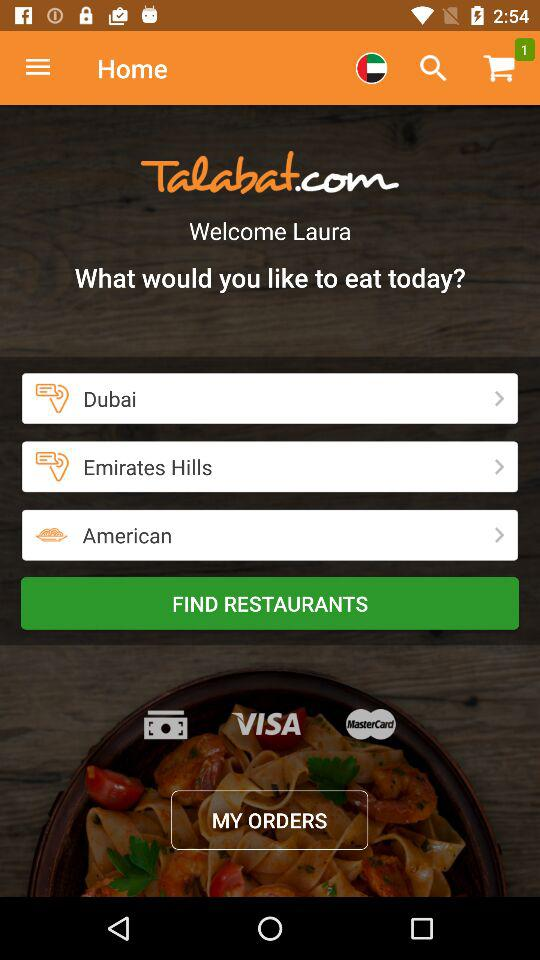How close is the restaurant?
When the provided information is insufficient, respond with <no answer>. <no answer> 